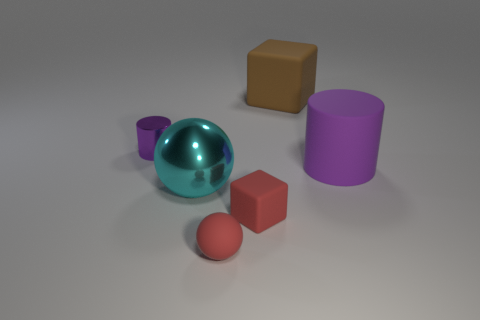What number of other objects are there of the same material as the tiny purple cylinder? Aside from the tiny purple cylinder, there is 1 other object of the same material, which is the purple cylinder with a bigger size, showcasing a consistent visual texture that indicates they are made from identical material. 